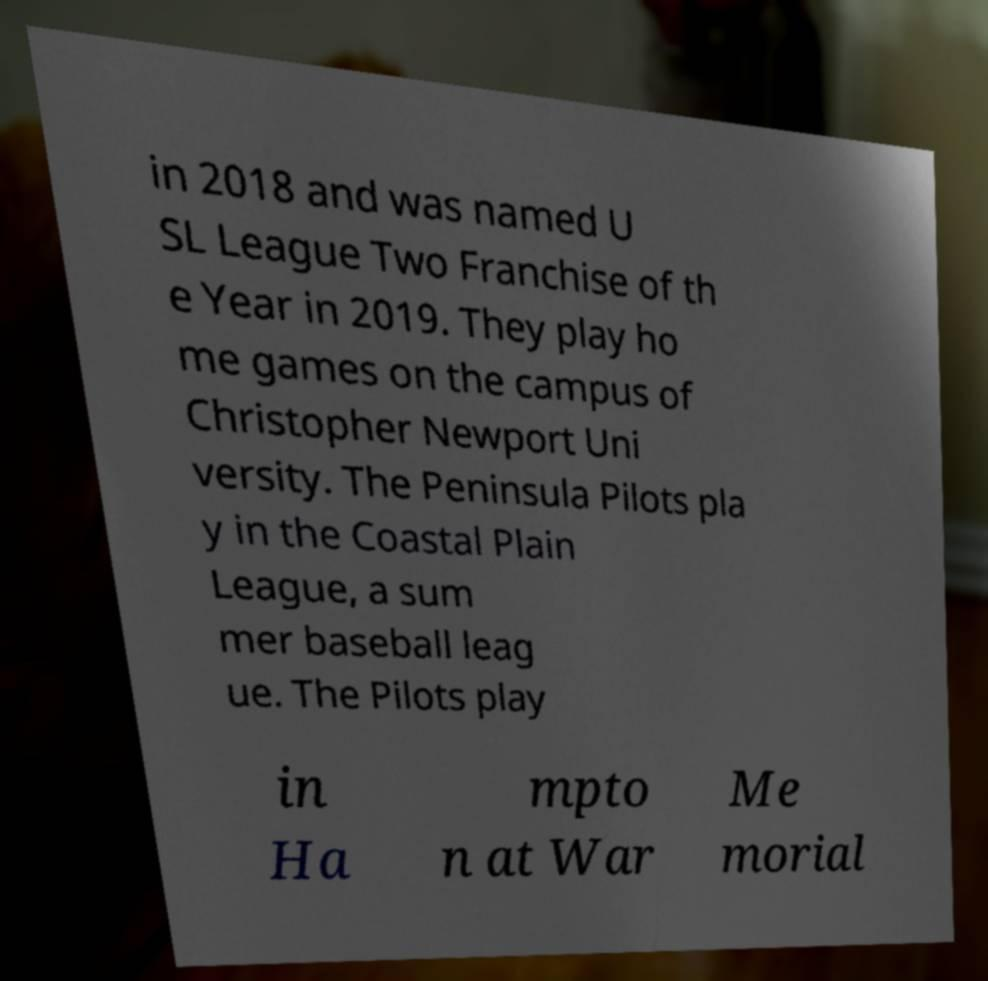For documentation purposes, I need the text within this image transcribed. Could you provide that? in 2018 and was named U SL League Two Franchise of th e Year in 2019. They play ho me games on the campus of Christopher Newport Uni versity. The Peninsula Pilots pla y in the Coastal Plain League, a sum mer baseball leag ue. The Pilots play in Ha mpto n at War Me morial 